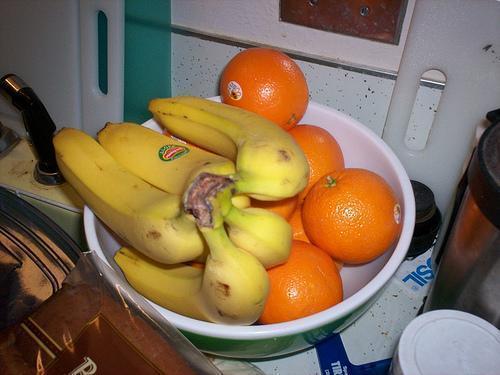How many oranges have been peeled?
Give a very brief answer. 0. How many bananas are in the picture?
Give a very brief answer. 2. How many oranges are there?
Give a very brief answer. 4. 